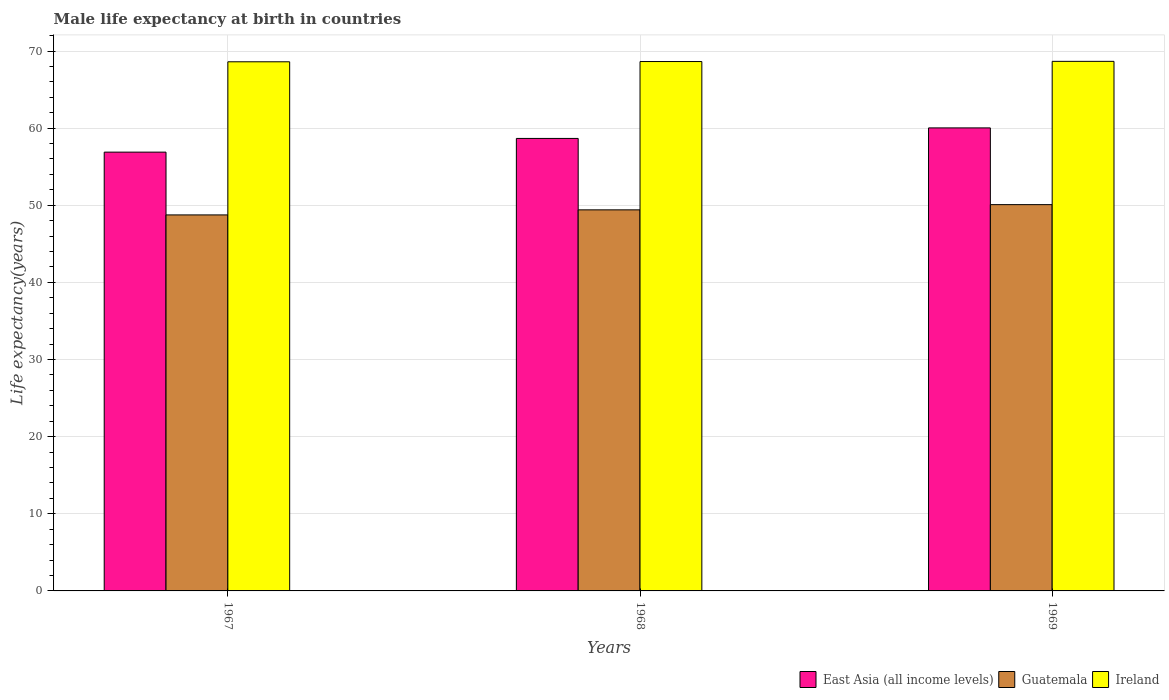How many groups of bars are there?
Provide a succinct answer. 3. Are the number of bars on each tick of the X-axis equal?
Keep it short and to the point. Yes. How many bars are there on the 1st tick from the left?
Provide a short and direct response. 3. How many bars are there on the 2nd tick from the right?
Your answer should be compact. 3. What is the label of the 1st group of bars from the left?
Ensure brevity in your answer.  1967. In how many cases, is the number of bars for a given year not equal to the number of legend labels?
Your answer should be compact. 0. What is the male life expectancy at birth in Ireland in 1968?
Keep it short and to the point. 68.64. Across all years, what is the maximum male life expectancy at birth in Guatemala?
Provide a short and direct response. 50.08. Across all years, what is the minimum male life expectancy at birth in East Asia (all income levels)?
Keep it short and to the point. 56.89. In which year was the male life expectancy at birth in East Asia (all income levels) maximum?
Give a very brief answer. 1969. In which year was the male life expectancy at birth in Guatemala minimum?
Give a very brief answer. 1967. What is the total male life expectancy at birth in Guatemala in the graph?
Your answer should be very brief. 148.24. What is the difference between the male life expectancy at birth in Ireland in 1967 and that in 1969?
Give a very brief answer. -0.06. What is the difference between the male life expectancy at birth in Ireland in 1968 and the male life expectancy at birth in Guatemala in 1969?
Provide a succinct answer. 18.55. What is the average male life expectancy at birth in Ireland per year?
Ensure brevity in your answer.  68.63. In the year 1967, what is the difference between the male life expectancy at birth in East Asia (all income levels) and male life expectancy at birth in Ireland?
Provide a short and direct response. -11.71. What is the ratio of the male life expectancy at birth in Ireland in 1967 to that in 1968?
Your response must be concise. 1. What is the difference between the highest and the second highest male life expectancy at birth in Guatemala?
Provide a short and direct response. 0.68. What is the difference between the highest and the lowest male life expectancy at birth in Guatemala?
Offer a very short reply. 1.33. Is the sum of the male life expectancy at birth in East Asia (all income levels) in 1968 and 1969 greater than the maximum male life expectancy at birth in Guatemala across all years?
Keep it short and to the point. Yes. What does the 3rd bar from the left in 1969 represents?
Offer a terse response. Ireland. What does the 3rd bar from the right in 1968 represents?
Keep it short and to the point. East Asia (all income levels). Is it the case that in every year, the sum of the male life expectancy at birth in Ireland and male life expectancy at birth in East Asia (all income levels) is greater than the male life expectancy at birth in Guatemala?
Provide a short and direct response. Yes. Are all the bars in the graph horizontal?
Your response must be concise. No. What is the difference between two consecutive major ticks on the Y-axis?
Your answer should be compact. 10. Are the values on the major ticks of Y-axis written in scientific E-notation?
Your response must be concise. No. Does the graph contain grids?
Your response must be concise. Yes. Where does the legend appear in the graph?
Offer a terse response. Bottom right. How many legend labels are there?
Your answer should be compact. 3. How are the legend labels stacked?
Your answer should be very brief. Horizontal. What is the title of the graph?
Keep it short and to the point. Male life expectancy at birth in countries. Does "Liechtenstein" appear as one of the legend labels in the graph?
Make the answer very short. No. What is the label or title of the Y-axis?
Your answer should be compact. Life expectancy(years). What is the Life expectancy(years) in East Asia (all income levels) in 1967?
Provide a succinct answer. 56.89. What is the Life expectancy(years) of Guatemala in 1967?
Provide a succinct answer. 48.75. What is the Life expectancy(years) in Ireland in 1967?
Give a very brief answer. 68.6. What is the Life expectancy(years) in East Asia (all income levels) in 1968?
Give a very brief answer. 58.67. What is the Life expectancy(years) of Guatemala in 1968?
Keep it short and to the point. 49.41. What is the Life expectancy(years) of Ireland in 1968?
Keep it short and to the point. 68.64. What is the Life expectancy(years) in East Asia (all income levels) in 1969?
Your answer should be very brief. 60.03. What is the Life expectancy(years) in Guatemala in 1969?
Keep it short and to the point. 50.08. What is the Life expectancy(years) of Ireland in 1969?
Give a very brief answer. 68.66. Across all years, what is the maximum Life expectancy(years) of East Asia (all income levels)?
Make the answer very short. 60.03. Across all years, what is the maximum Life expectancy(years) in Guatemala?
Your response must be concise. 50.08. Across all years, what is the maximum Life expectancy(years) in Ireland?
Give a very brief answer. 68.66. Across all years, what is the minimum Life expectancy(years) in East Asia (all income levels)?
Your answer should be very brief. 56.89. Across all years, what is the minimum Life expectancy(years) of Guatemala?
Provide a short and direct response. 48.75. Across all years, what is the minimum Life expectancy(years) of Ireland?
Keep it short and to the point. 68.6. What is the total Life expectancy(years) of East Asia (all income levels) in the graph?
Ensure brevity in your answer.  175.59. What is the total Life expectancy(years) of Guatemala in the graph?
Provide a succinct answer. 148.24. What is the total Life expectancy(years) of Ireland in the graph?
Provide a succinct answer. 205.9. What is the difference between the Life expectancy(years) in East Asia (all income levels) in 1967 and that in 1968?
Provide a short and direct response. -1.77. What is the difference between the Life expectancy(years) in Guatemala in 1967 and that in 1968?
Your answer should be very brief. -0.66. What is the difference between the Life expectancy(years) in Ireland in 1967 and that in 1968?
Your response must be concise. -0.03. What is the difference between the Life expectancy(years) in East Asia (all income levels) in 1967 and that in 1969?
Your response must be concise. -3.14. What is the difference between the Life expectancy(years) in Guatemala in 1967 and that in 1969?
Give a very brief answer. -1.33. What is the difference between the Life expectancy(years) of Ireland in 1967 and that in 1969?
Keep it short and to the point. -0.06. What is the difference between the Life expectancy(years) in East Asia (all income levels) in 1968 and that in 1969?
Offer a terse response. -1.37. What is the difference between the Life expectancy(years) in Guatemala in 1968 and that in 1969?
Give a very brief answer. -0.68. What is the difference between the Life expectancy(years) of Ireland in 1968 and that in 1969?
Offer a very short reply. -0.02. What is the difference between the Life expectancy(years) of East Asia (all income levels) in 1967 and the Life expectancy(years) of Guatemala in 1968?
Ensure brevity in your answer.  7.48. What is the difference between the Life expectancy(years) of East Asia (all income levels) in 1967 and the Life expectancy(years) of Ireland in 1968?
Your answer should be compact. -11.74. What is the difference between the Life expectancy(years) in Guatemala in 1967 and the Life expectancy(years) in Ireland in 1968?
Provide a succinct answer. -19.89. What is the difference between the Life expectancy(years) in East Asia (all income levels) in 1967 and the Life expectancy(years) in Guatemala in 1969?
Give a very brief answer. 6.81. What is the difference between the Life expectancy(years) of East Asia (all income levels) in 1967 and the Life expectancy(years) of Ireland in 1969?
Give a very brief answer. -11.77. What is the difference between the Life expectancy(years) of Guatemala in 1967 and the Life expectancy(years) of Ireland in 1969?
Keep it short and to the point. -19.91. What is the difference between the Life expectancy(years) of East Asia (all income levels) in 1968 and the Life expectancy(years) of Guatemala in 1969?
Give a very brief answer. 8.58. What is the difference between the Life expectancy(years) of East Asia (all income levels) in 1968 and the Life expectancy(years) of Ireland in 1969?
Your answer should be compact. -9.99. What is the difference between the Life expectancy(years) of Guatemala in 1968 and the Life expectancy(years) of Ireland in 1969?
Give a very brief answer. -19.25. What is the average Life expectancy(years) in East Asia (all income levels) per year?
Your answer should be compact. 58.53. What is the average Life expectancy(years) in Guatemala per year?
Give a very brief answer. 49.41. What is the average Life expectancy(years) in Ireland per year?
Give a very brief answer. 68.63. In the year 1967, what is the difference between the Life expectancy(years) of East Asia (all income levels) and Life expectancy(years) of Guatemala?
Ensure brevity in your answer.  8.14. In the year 1967, what is the difference between the Life expectancy(years) in East Asia (all income levels) and Life expectancy(years) in Ireland?
Offer a terse response. -11.71. In the year 1967, what is the difference between the Life expectancy(years) of Guatemala and Life expectancy(years) of Ireland?
Ensure brevity in your answer.  -19.85. In the year 1968, what is the difference between the Life expectancy(years) in East Asia (all income levels) and Life expectancy(years) in Guatemala?
Offer a terse response. 9.26. In the year 1968, what is the difference between the Life expectancy(years) in East Asia (all income levels) and Life expectancy(years) in Ireland?
Keep it short and to the point. -9.97. In the year 1968, what is the difference between the Life expectancy(years) in Guatemala and Life expectancy(years) in Ireland?
Your answer should be compact. -19.23. In the year 1969, what is the difference between the Life expectancy(years) in East Asia (all income levels) and Life expectancy(years) in Guatemala?
Make the answer very short. 9.95. In the year 1969, what is the difference between the Life expectancy(years) of East Asia (all income levels) and Life expectancy(years) of Ireland?
Offer a terse response. -8.63. In the year 1969, what is the difference between the Life expectancy(years) in Guatemala and Life expectancy(years) in Ireland?
Your answer should be compact. -18.58. What is the ratio of the Life expectancy(years) of East Asia (all income levels) in 1967 to that in 1968?
Your answer should be compact. 0.97. What is the ratio of the Life expectancy(years) of Guatemala in 1967 to that in 1968?
Give a very brief answer. 0.99. What is the ratio of the Life expectancy(years) of East Asia (all income levels) in 1967 to that in 1969?
Offer a terse response. 0.95. What is the ratio of the Life expectancy(years) of Guatemala in 1967 to that in 1969?
Provide a short and direct response. 0.97. What is the ratio of the Life expectancy(years) in East Asia (all income levels) in 1968 to that in 1969?
Your answer should be very brief. 0.98. What is the ratio of the Life expectancy(years) in Guatemala in 1968 to that in 1969?
Your answer should be very brief. 0.99. What is the difference between the highest and the second highest Life expectancy(years) in East Asia (all income levels)?
Give a very brief answer. 1.37. What is the difference between the highest and the second highest Life expectancy(years) in Guatemala?
Ensure brevity in your answer.  0.68. What is the difference between the highest and the second highest Life expectancy(years) of Ireland?
Ensure brevity in your answer.  0.02. What is the difference between the highest and the lowest Life expectancy(years) in East Asia (all income levels)?
Your answer should be very brief. 3.14. What is the difference between the highest and the lowest Life expectancy(years) in Guatemala?
Make the answer very short. 1.33. What is the difference between the highest and the lowest Life expectancy(years) of Ireland?
Make the answer very short. 0.06. 